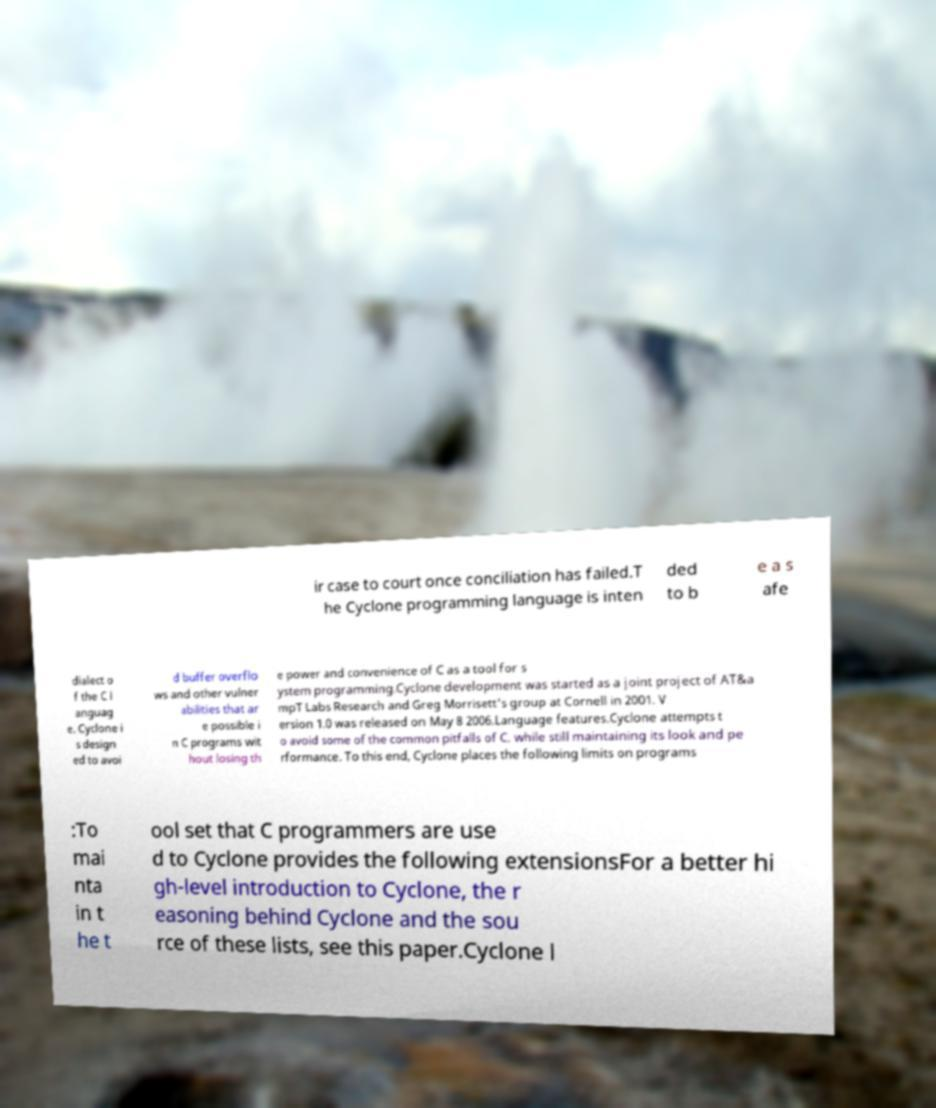What messages or text are displayed in this image? I need them in a readable, typed format. ir case to court once conciliation has failed.T he Cyclone programming language is inten ded to b e a s afe dialect o f the C l anguag e. Cyclone i s design ed to avoi d buffer overflo ws and other vulner abilities that ar e possible i n C programs wit hout losing th e power and convenience of C as a tool for s ystem programming.Cyclone development was started as a joint project of AT&a mpT Labs Research and Greg Morrisett's group at Cornell in 2001. V ersion 1.0 was released on May 8 2006.Language features.Cyclone attempts t o avoid some of the common pitfalls of C, while still maintaining its look and pe rformance. To this end, Cyclone places the following limits on programs :To mai nta in t he t ool set that C programmers are use d to Cyclone provides the following extensionsFor a better hi gh-level introduction to Cyclone, the r easoning behind Cyclone and the sou rce of these lists, see this paper.Cyclone l 